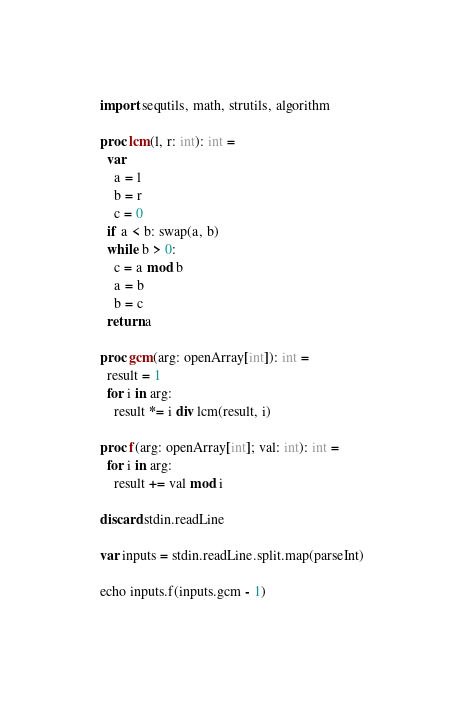Convert code to text. <code><loc_0><loc_0><loc_500><loc_500><_Nim_>import sequtils, math, strutils, algorithm

proc lcm(l, r: int): int =
  var
    a = l
    b = r
    c = 0
  if a < b: swap(a, b)
  while b > 0:
    c = a mod b
    a = b
    b = c
  return a

proc gcm(arg: openArray[int]): int =
  result = 1
  for i in arg:
    result *= i div lcm(result, i)

proc f(arg: openArray[int]; val: int): int =
  for i in arg:
    result += val mod i

discard stdin.readLine

var inputs = stdin.readLine.split.map(parseInt)

echo inputs.f(inputs.gcm - 1)
</code> 